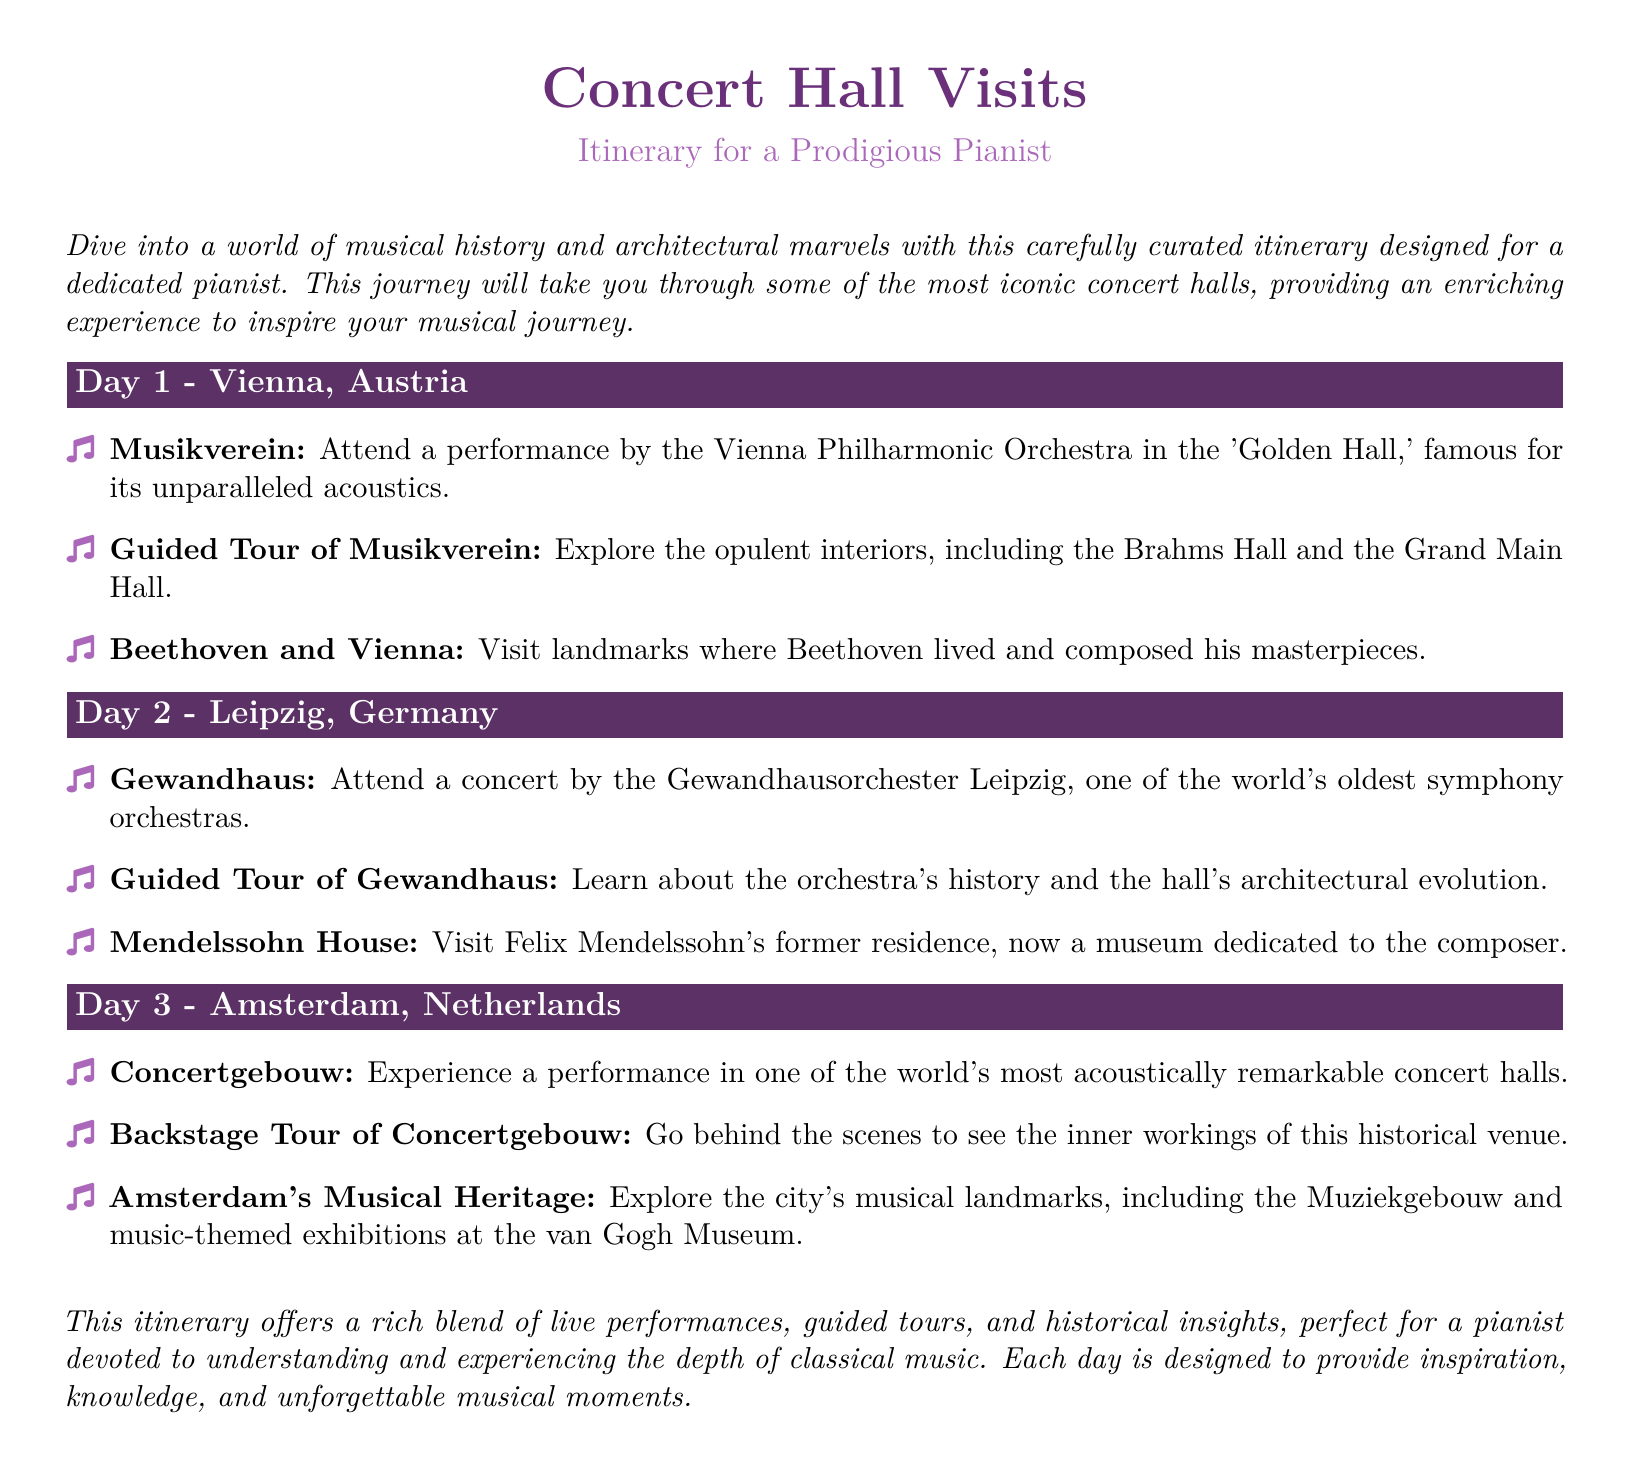What city is featured on Day 1? The itinerary specifies that Day 1 is dedicated to Vienna, Austria.
Answer: Vienna, Austria Which concert hall is associated with the Vienna Philharmonic Orchestra? The document states that the performance will take place at the Musikverein.
Answer: Musikverein What performance can you attend on Day 2? The itinerary mentions a concert by the Gewandhausorchester Leipzig on Day 2.
Answer: Concert by Gewandhausorchester Leipzig What type of tour is provided at the Concertgebouw? The itinerary lists a backstage tour of the Concertgebouw as part of the day's activities.
Answer: Backstage Tour How many days are included in the itinerary? The document outlines activities for three distinct days.
Answer: Three days Which composer's house can be visited in Leipzig? The itinerary indicates that Felix Mendelssohn's former residence can be visited.
Answer: Felix Mendelssohn What is a notable feature of the Concertgebouw mentioned in the document? The document describes the Concertgebouw as one of the world's most acoustically remarkable concert halls.
Answer: Acoustically remarkable What historical insights are you expected to gain from this itinerary? The itinerary emphasizes exploring landmarks related to significant composers and their contributions to music history.
Answer: Significant composers' landmarks 